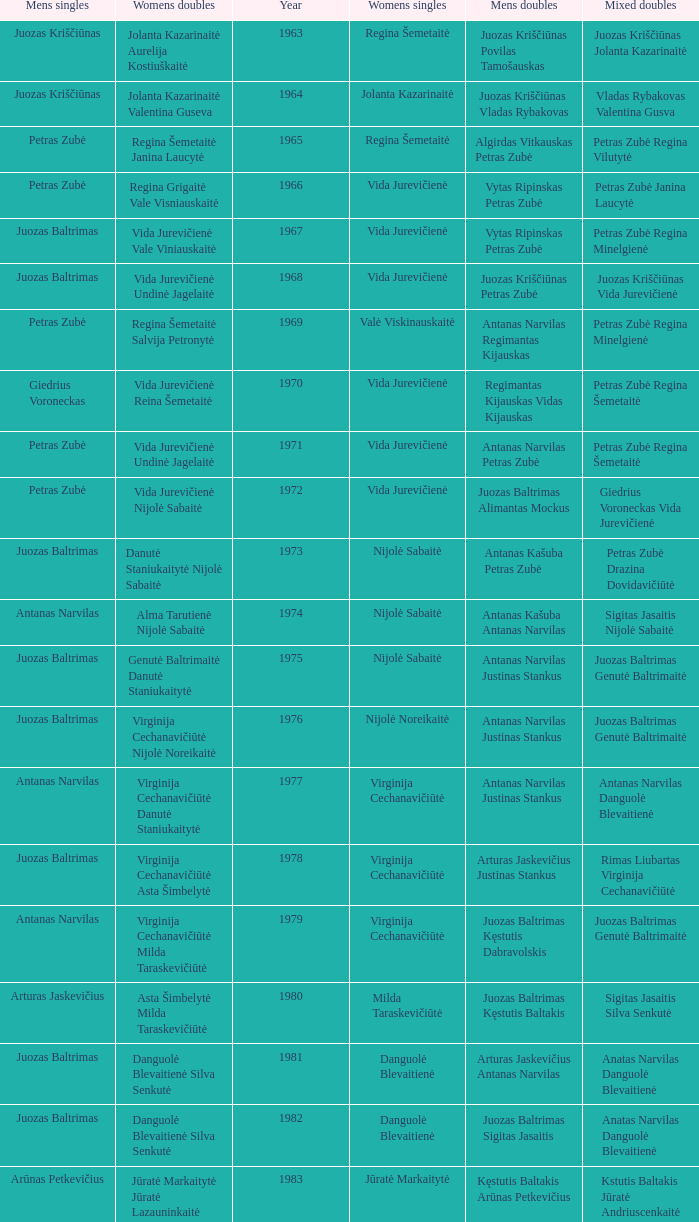How many years did aivaras kvedarauskas juozas spelveris participate in the men's doubles? 1.0. 